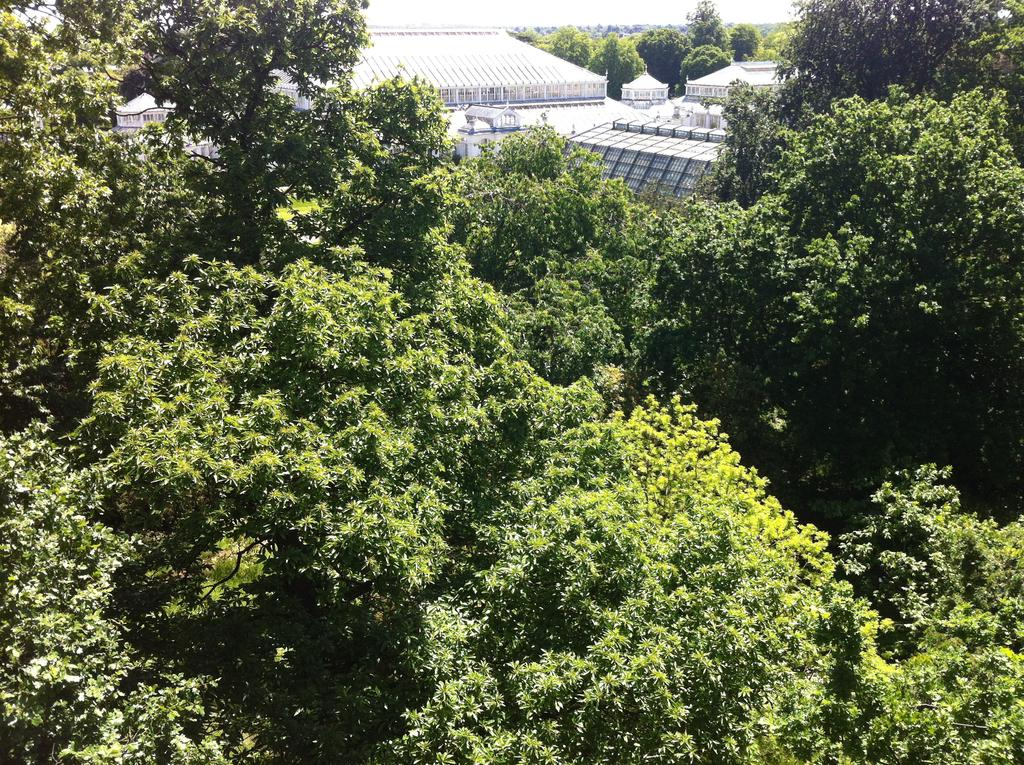What type of vegetation is present at the bottom of the image? There are trees at the bottom of the picture. What type of structures can be seen in the background of the image? There are buildings in the background of the image. What color are the buildings in the image? The buildings are white in color. Where is the mailbox located in the image? There is no mailbox present in the image. Are there any icicles hanging from the buildings in the image? There is no mention of icicles in the provided facts, so we cannot determine their presence from the image. Can you describe the cellar in the image? There is no mention of a cellar in the provided facts, so we cannot describe it from the image. 